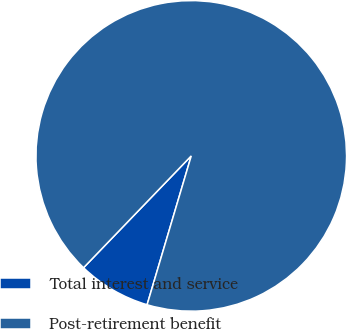<chart> <loc_0><loc_0><loc_500><loc_500><pie_chart><fcel>Total interest and service<fcel>Post-retirement benefit<nl><fcel>7.61%<fcel>92.39%<nl></chart> 